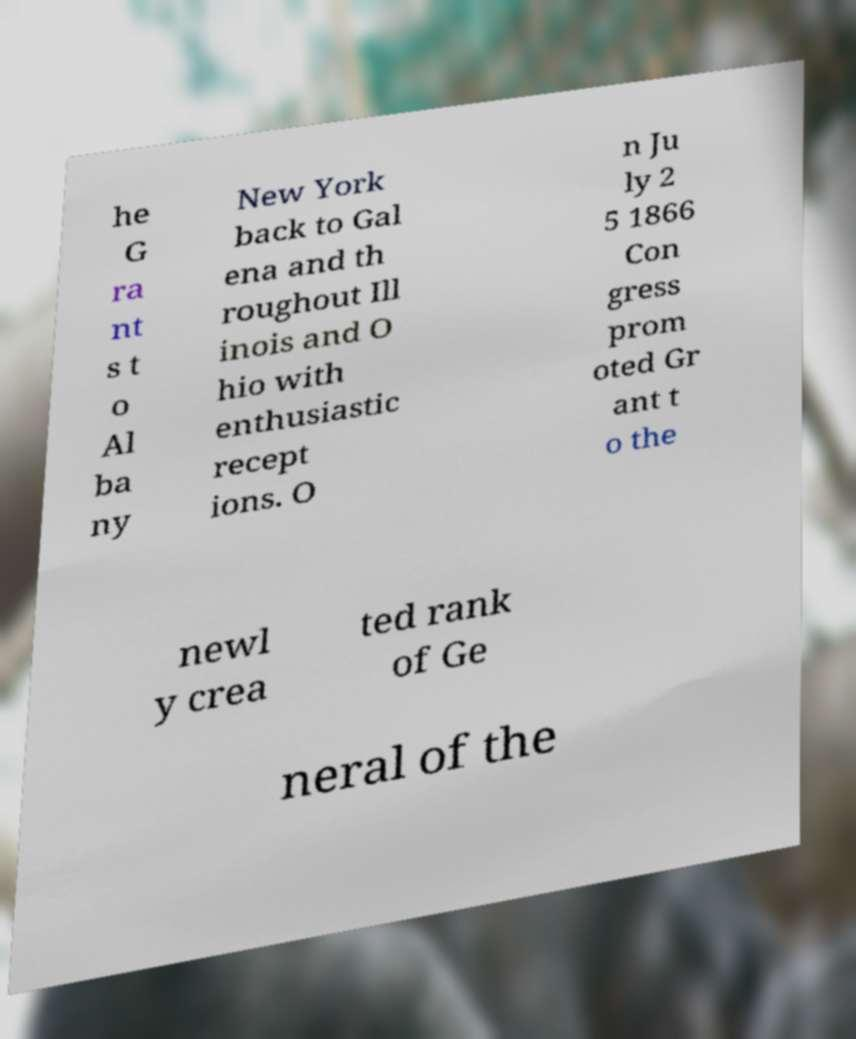Can you read and provide the text displayed in the image?This photo seems to have some interesting text. Can you extract and type it out for me? he G ra nt s t o Al ba ny New York back to Gal ena and th roughout Ill inois and O hio with enthusiastic recept ions. O n Ju ly 2 5 1866 Con gress prom oted Gr ant t o the newl y crea ted rank of Ge neral of the 